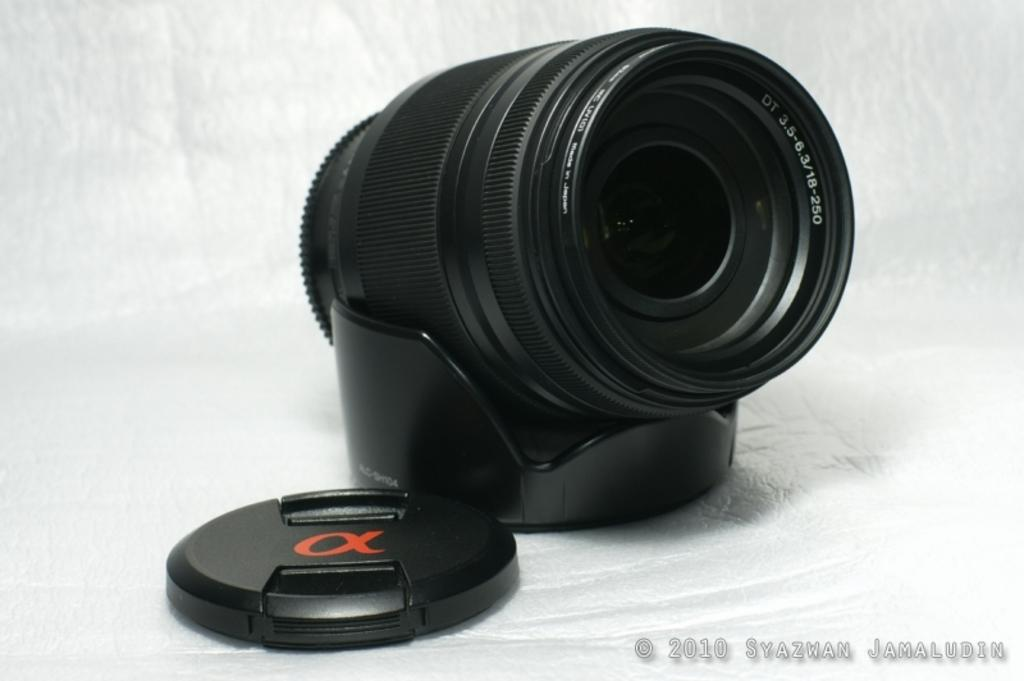<image>
Offer a succinct explanation of the picture presented. A black lens with a watermark of 2010 Syazwan Jamaludin on the bottom. 